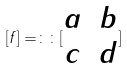Convert formula to latex. <formula><loc_0><loc_0><loc_500><loc_500>[ f ] = \colon \colon [ \begin{matrix} a & b \\ c & d \end{matrix} ]</formula> 